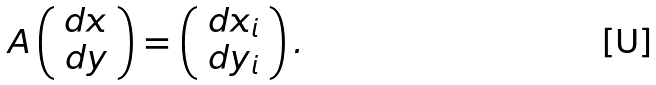<formula> <loc_0><loc_0><loc_500><loc_500>A \left ( \begin{array} { c } d x \\ d y \end{array} \right ) = \left ( \begin{array} { c } d x _ { i } \\ d y _ { i } \end{array} \right ) .</formula> 